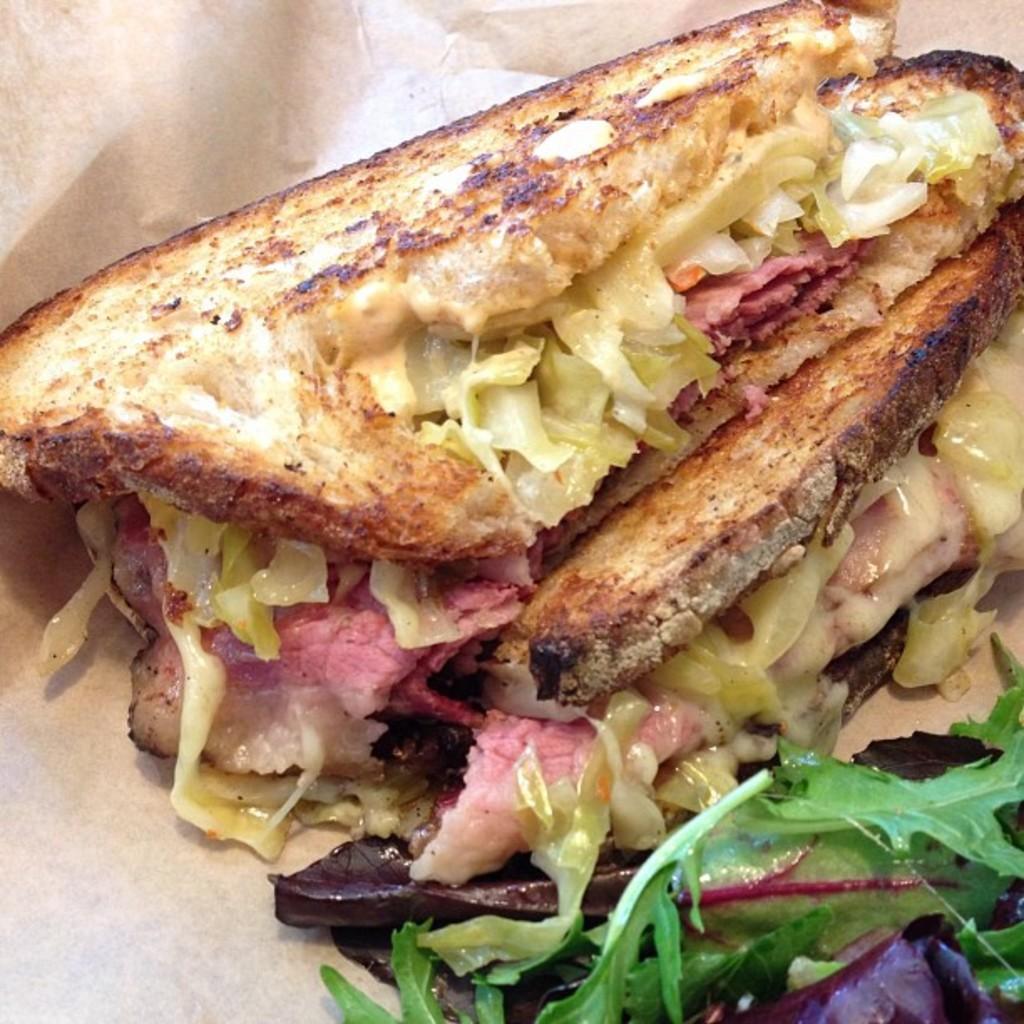Could you give a brief overview of what you see in this image? In this image there is food on an object, the background of the image is white in color. 